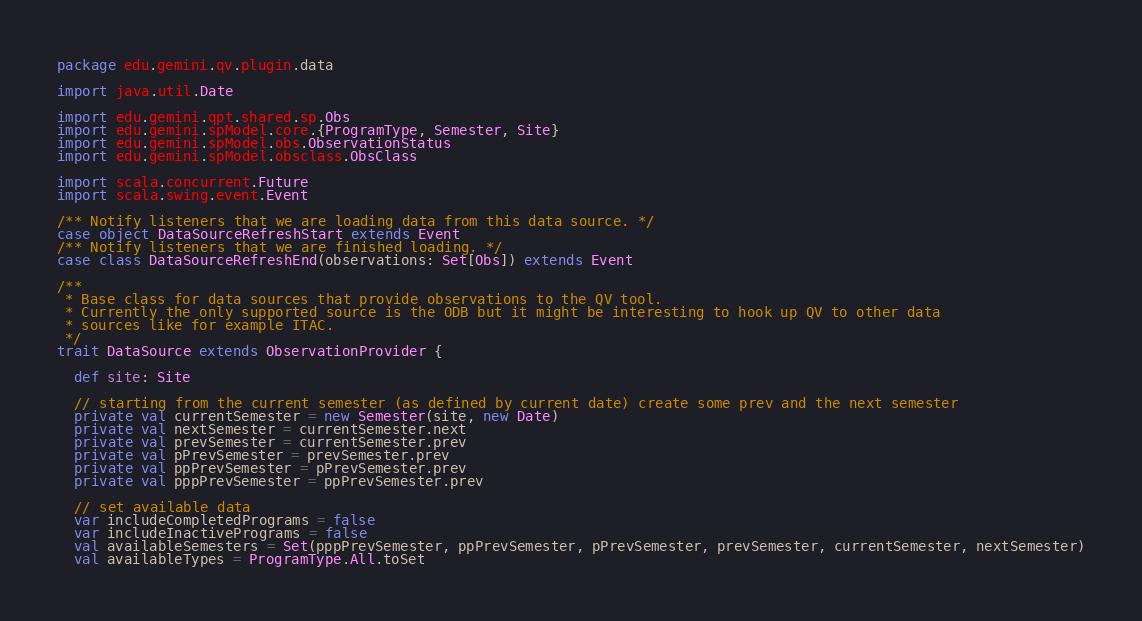<code> <loc_0><loc_0><loc_500><loc_500><_Scala_>package edu.gemini.qv.plugin.data

import java.util.Date

import edu.gemini.qpt.shared.sp.Obs
import edu.gemini.spModel.core.{ProgramType, Semester, Site}
import edu.gemini.spModel.obs.ObservationStatus
import edu.gemini.spModel.obsclass.ObsClass

import scala.concurrent.Future
import scala.swing.event.Event

/** Notify listeners that we are loading data from this data source. */
case object DataSourceRefreshStart extends Event
/** Notify listeners that we are finished loading. */
case class DataSourceRefreshEnd(observations: Set[Obs]) extends Event

/**
 * Base class for data sources that provide observations to the QV tool.
 * Currently the only supported source is the ODB but it might be interesting to hook up QV to other data
 * sources like for example ITAC.
 */
trait DataSource extends ObservationProvider {

  def site: Site

  // starting from the current semester (as defined by current date) create some prev and the next semester
  private val currentSemester = new Semester(site, new Date)
  private val nextSemester = currentSemester.next
  private val prevSemester = currentSemester.prev
  private val pPrevSemester = prevSemester.prev
  private val ppPrevSemester = pPrevSemester.prev
  private val pppPrevSemester = ppPrevSemester.prev

  // set available data
  var includeCompletedPrograms = false
  var includeInactivePrograms = false
  val availableSemesters = Set(pppPrevSemester, ppPrevSemester, pPrevSemester, prevSemester, currentSemester, nextSemester)
  val availableTypes = ProgramType.All.toSet</code> 